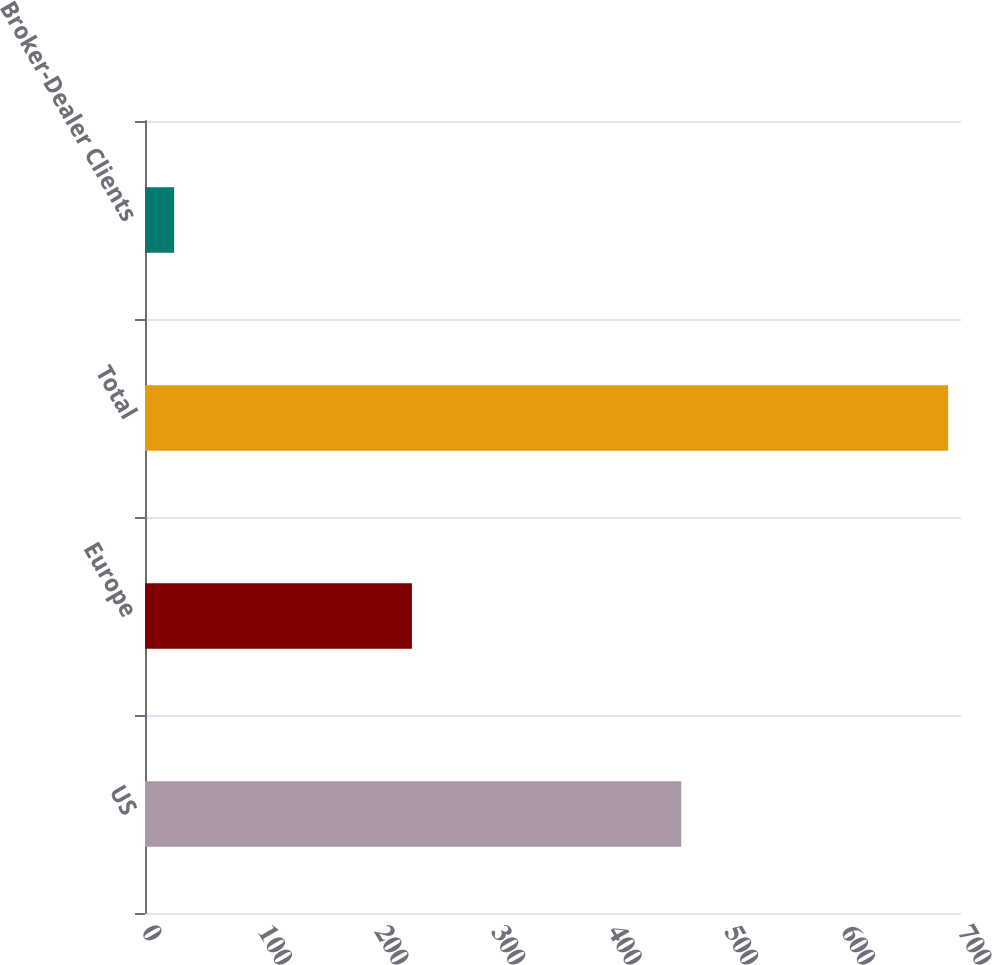Convert chart. <chart><loc_0><loc_0><loc_500><loc_500><bar_chart><fcel>US<fcel>Europe<fcel>Total<fcel>Broker-Dealer Clients<nl><fcel>460<fcel>229<fcel>689<fcel>25<nl></chart> 